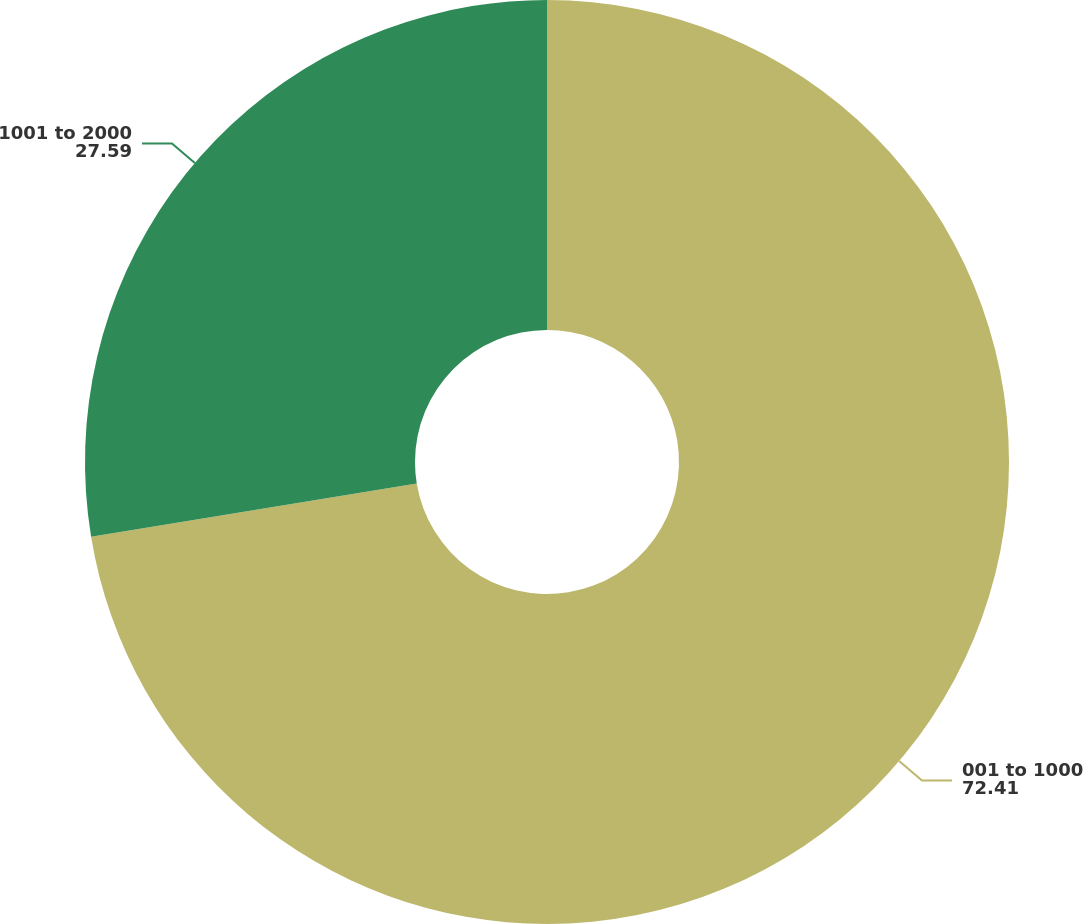Convert chart. <chart><loc_0><loc_0><loc_500><loc_500><pie_chart><fcel>001 to 1000<fcel>1001 to 2000<nl><fcel>72.41%<fcel>27.59%<nl></chart> 